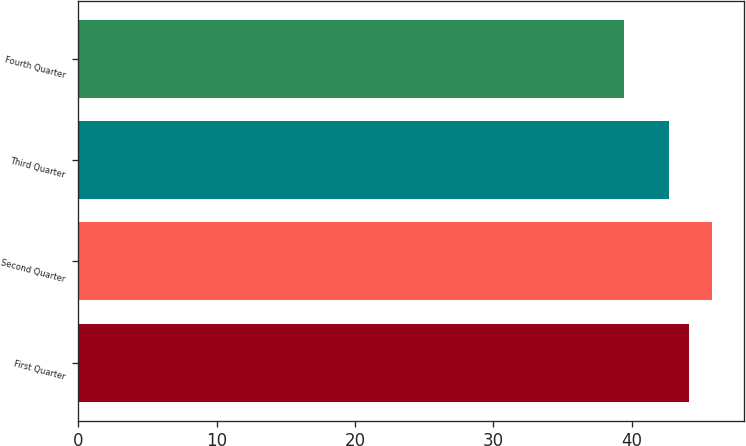<chart> <loc_0><loc_0><loc_500><loc_500><bar_chart><fcel>First Quarter<fcel>Second Quarter<fcel>Third Quarter<fcel>Fourth Quarter<nl><fcel>44.12<fcel>45.81<fcel>42.7<fcel>39.46<nl></chart> 